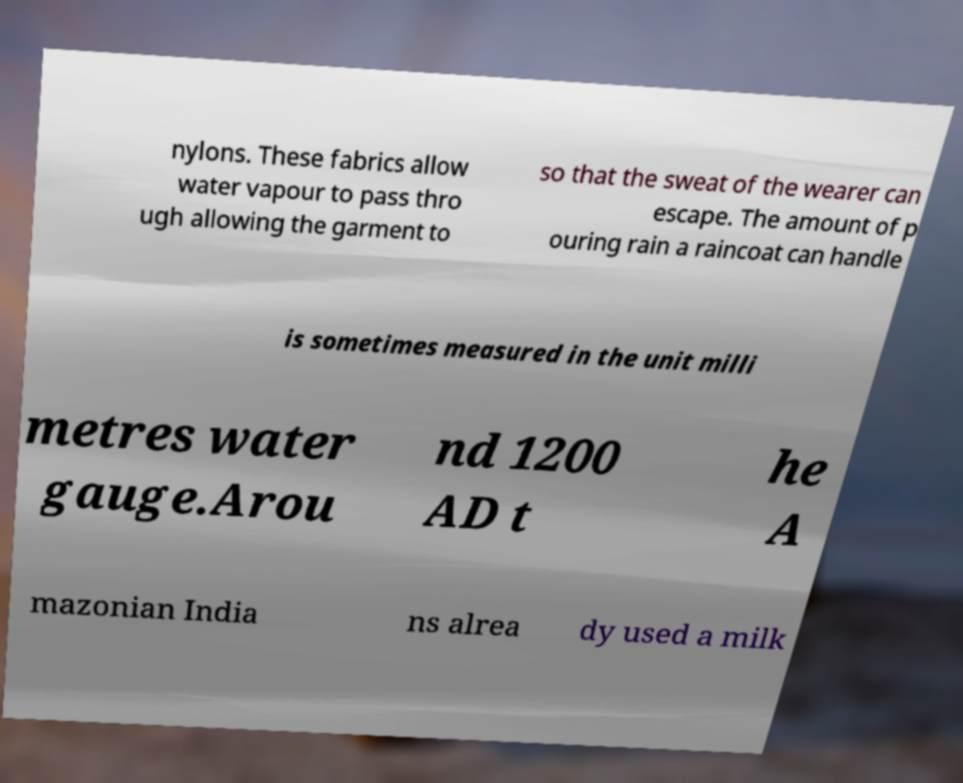There's text embedded in this image that I need extracted. Can you transcribe it verbatim? nylons. These fabrics allow water vapour to pass thro ugh allowing the garment to so that the sweat of the wearer can escape. The amount of p ouring rain a raincoat can handle is sometimes measured in the unit milli metres water gauge.Arou nd 1200 AD t he A mazonian India ns alrea dy used a milk 